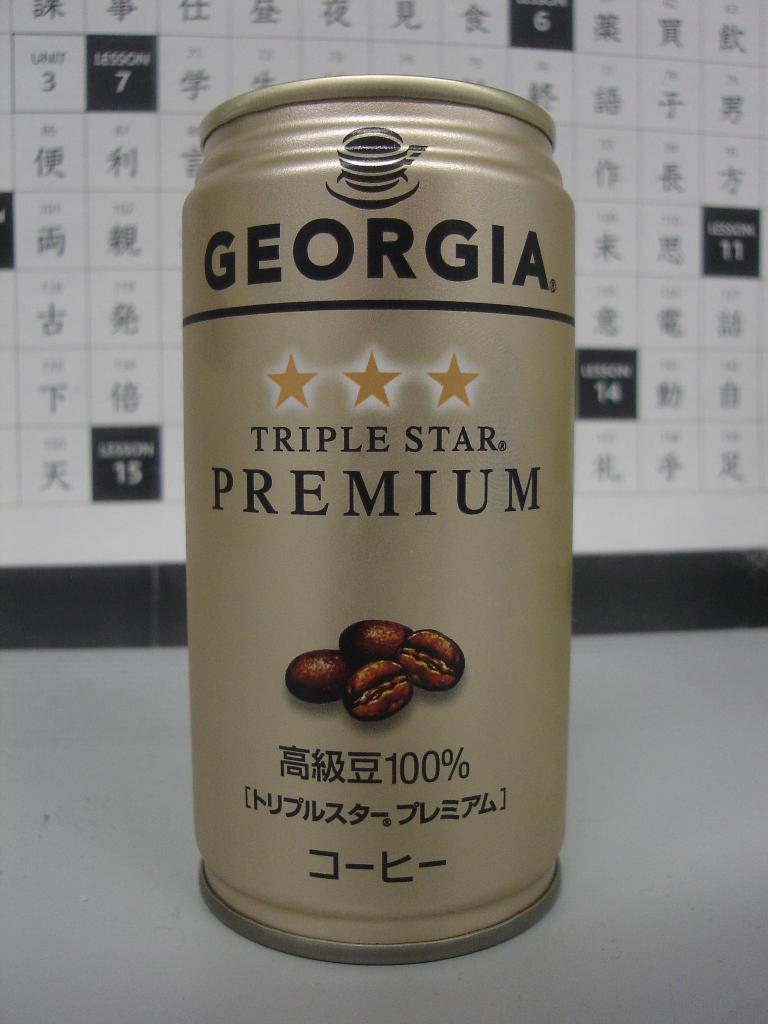What brand is the maker of this drink?
Make the answer very short. Georgia. How many stars is this premium drink?
Provide a short and direct response. 3. 